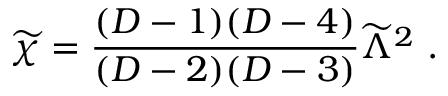Convert formula to latex. <formula><loc_0><loc_0><loc_500><loc_500>{ \widetilde { \chi } } = { \frac { ( D - 1 ) ( D - 4 ) } { ( D - 2 ) ( D - 3 ) } } { \widetilde { \Lambda } } ^ { 2 } .</formula> 